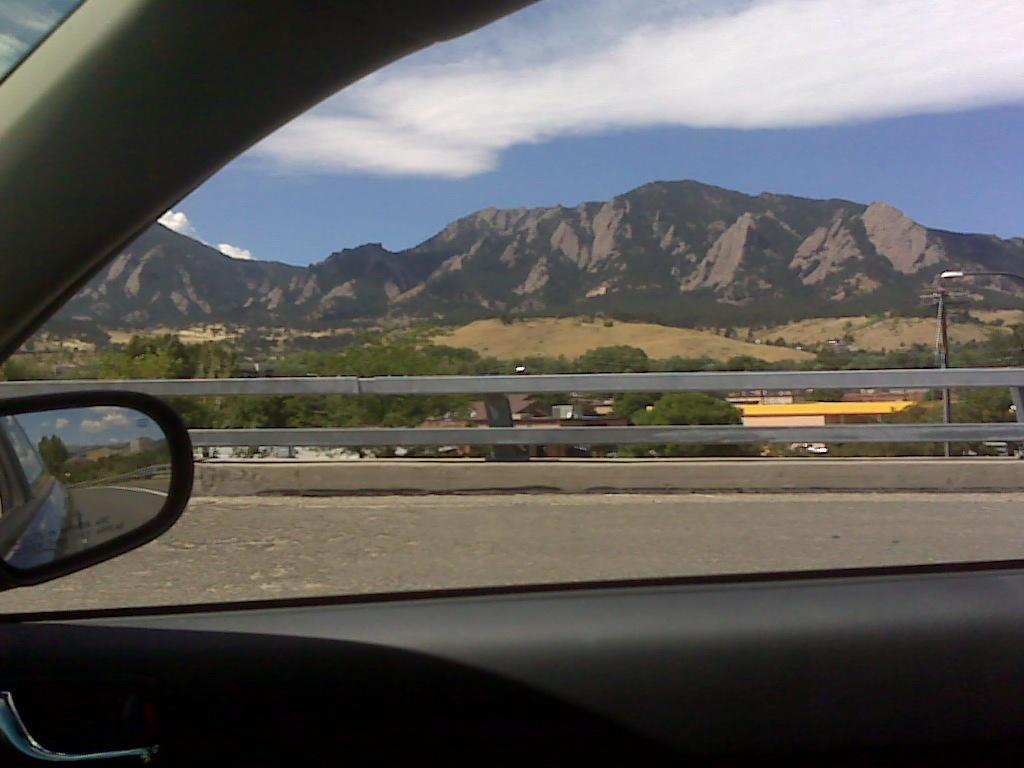What is the setting of the image? The image is captured from inside a car. What can be seen outside the car window? There are mountains, trees, and a road visible behind the window. What type of cork is being used to seal the car window in the image? There is no cork present in the image, and the car window is not being sealed. What kind of plastic material is visible in the image? The provided facts do not mention any specific plastic material in the image. 